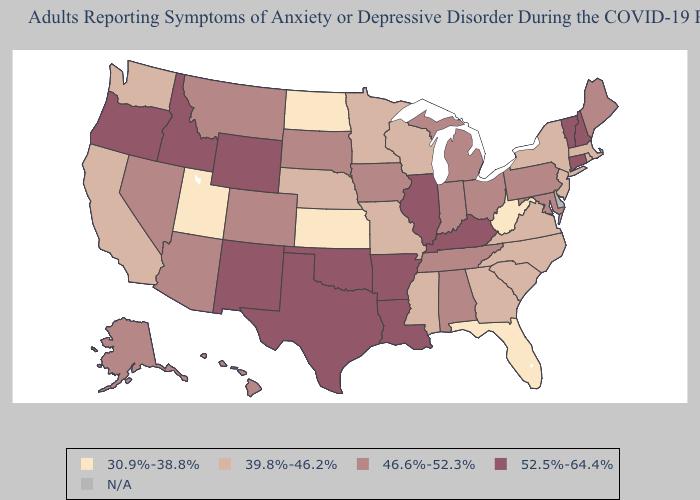How many symbols are there in the legend?
Keep it brief. 5. Does Kentucky have the highest value in the USA?
Quick response, please. Yes. Is the legend a continuous bar?
Answer briefly. No. Name the states that have a value in the range 52.5%-64.4%?
Answer briefly. Arkansas, Connecticut, Idaho, Illinois, Kentucky, Louisiana, New Hampshire, New Mexico, Oklahoma, Oregon, Texas, Vermont, Wyoming. Which states have the highest value in the USA?
Keep it brief. Arkansas, Connecticut, Idaho, Illinois, Kentucky, Louisiana, New Hampshire, New Mexico, Oklahoma, Oregon, Texas, Vermont, Wyoming. Name the states that have a value in the range 46.6%-52.3%?
Give a very brief answer. Alabama, Alaska, Arizona, Colorado, Hawaii, Indiana, Iowa, Maine, Maryland, Michigan, Montana, Nevada, Ohio, Pennsylvania, South Dakota, Tennessee. What is the highest value in states that border North Dakota?
Keep it brief. 46.6%-52.3%. Name the states that have a value in the range 46.6%-52.3%?
Short answer required. Alabama, Alaska, Arizona, Colorado, Hawaii, Indiana, Iowa, Maine, Maryland, Michigan, Montana, Nevada, Ohio, Pennsylvania, South Dakota, Tennessee. What is the lowest value in the USA?
Give a very brief answer. 30.9%-38.8%. Name the states that have a value in the range 46.6%-52.3%?
Be succinct. Alabama, Alaska, Arizona, Colorado, Hawaii, Indiana, Iowa, Maine, Maryland, Michigan, Montana, Nevada, Ohio, Pennsylvania, South Dakota, Tennessee. How many symbols are there in the legend?
Answer briefly. 5. What is the lowest value in the MidWest?
Be succinct. 30.9%-38.8%. Name the states that have a value in the range N/A?
Quick response, please. Delaware. What is the lowest value in states that border North Dakota?
Keep it brief. 39.8%-46.2%. What is the value of Oregon?
Write a very short answer. 52.5%-64.4%. 